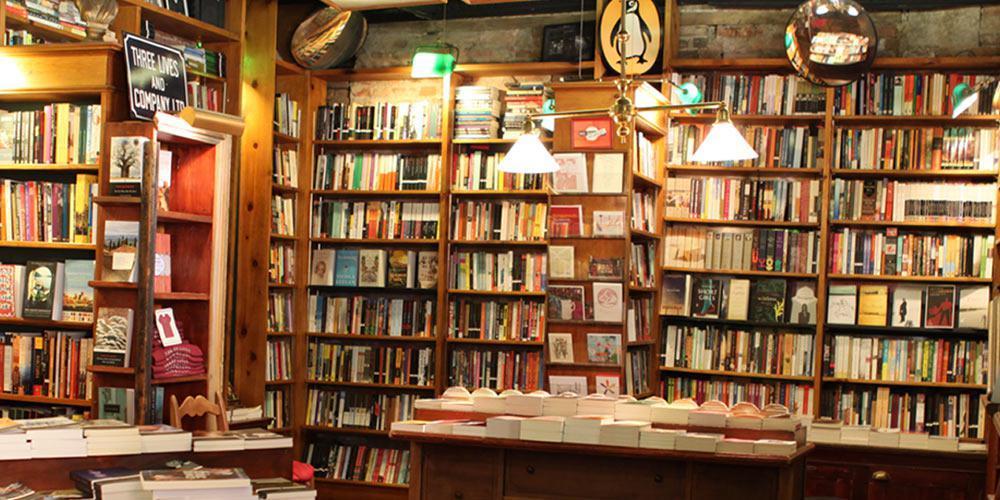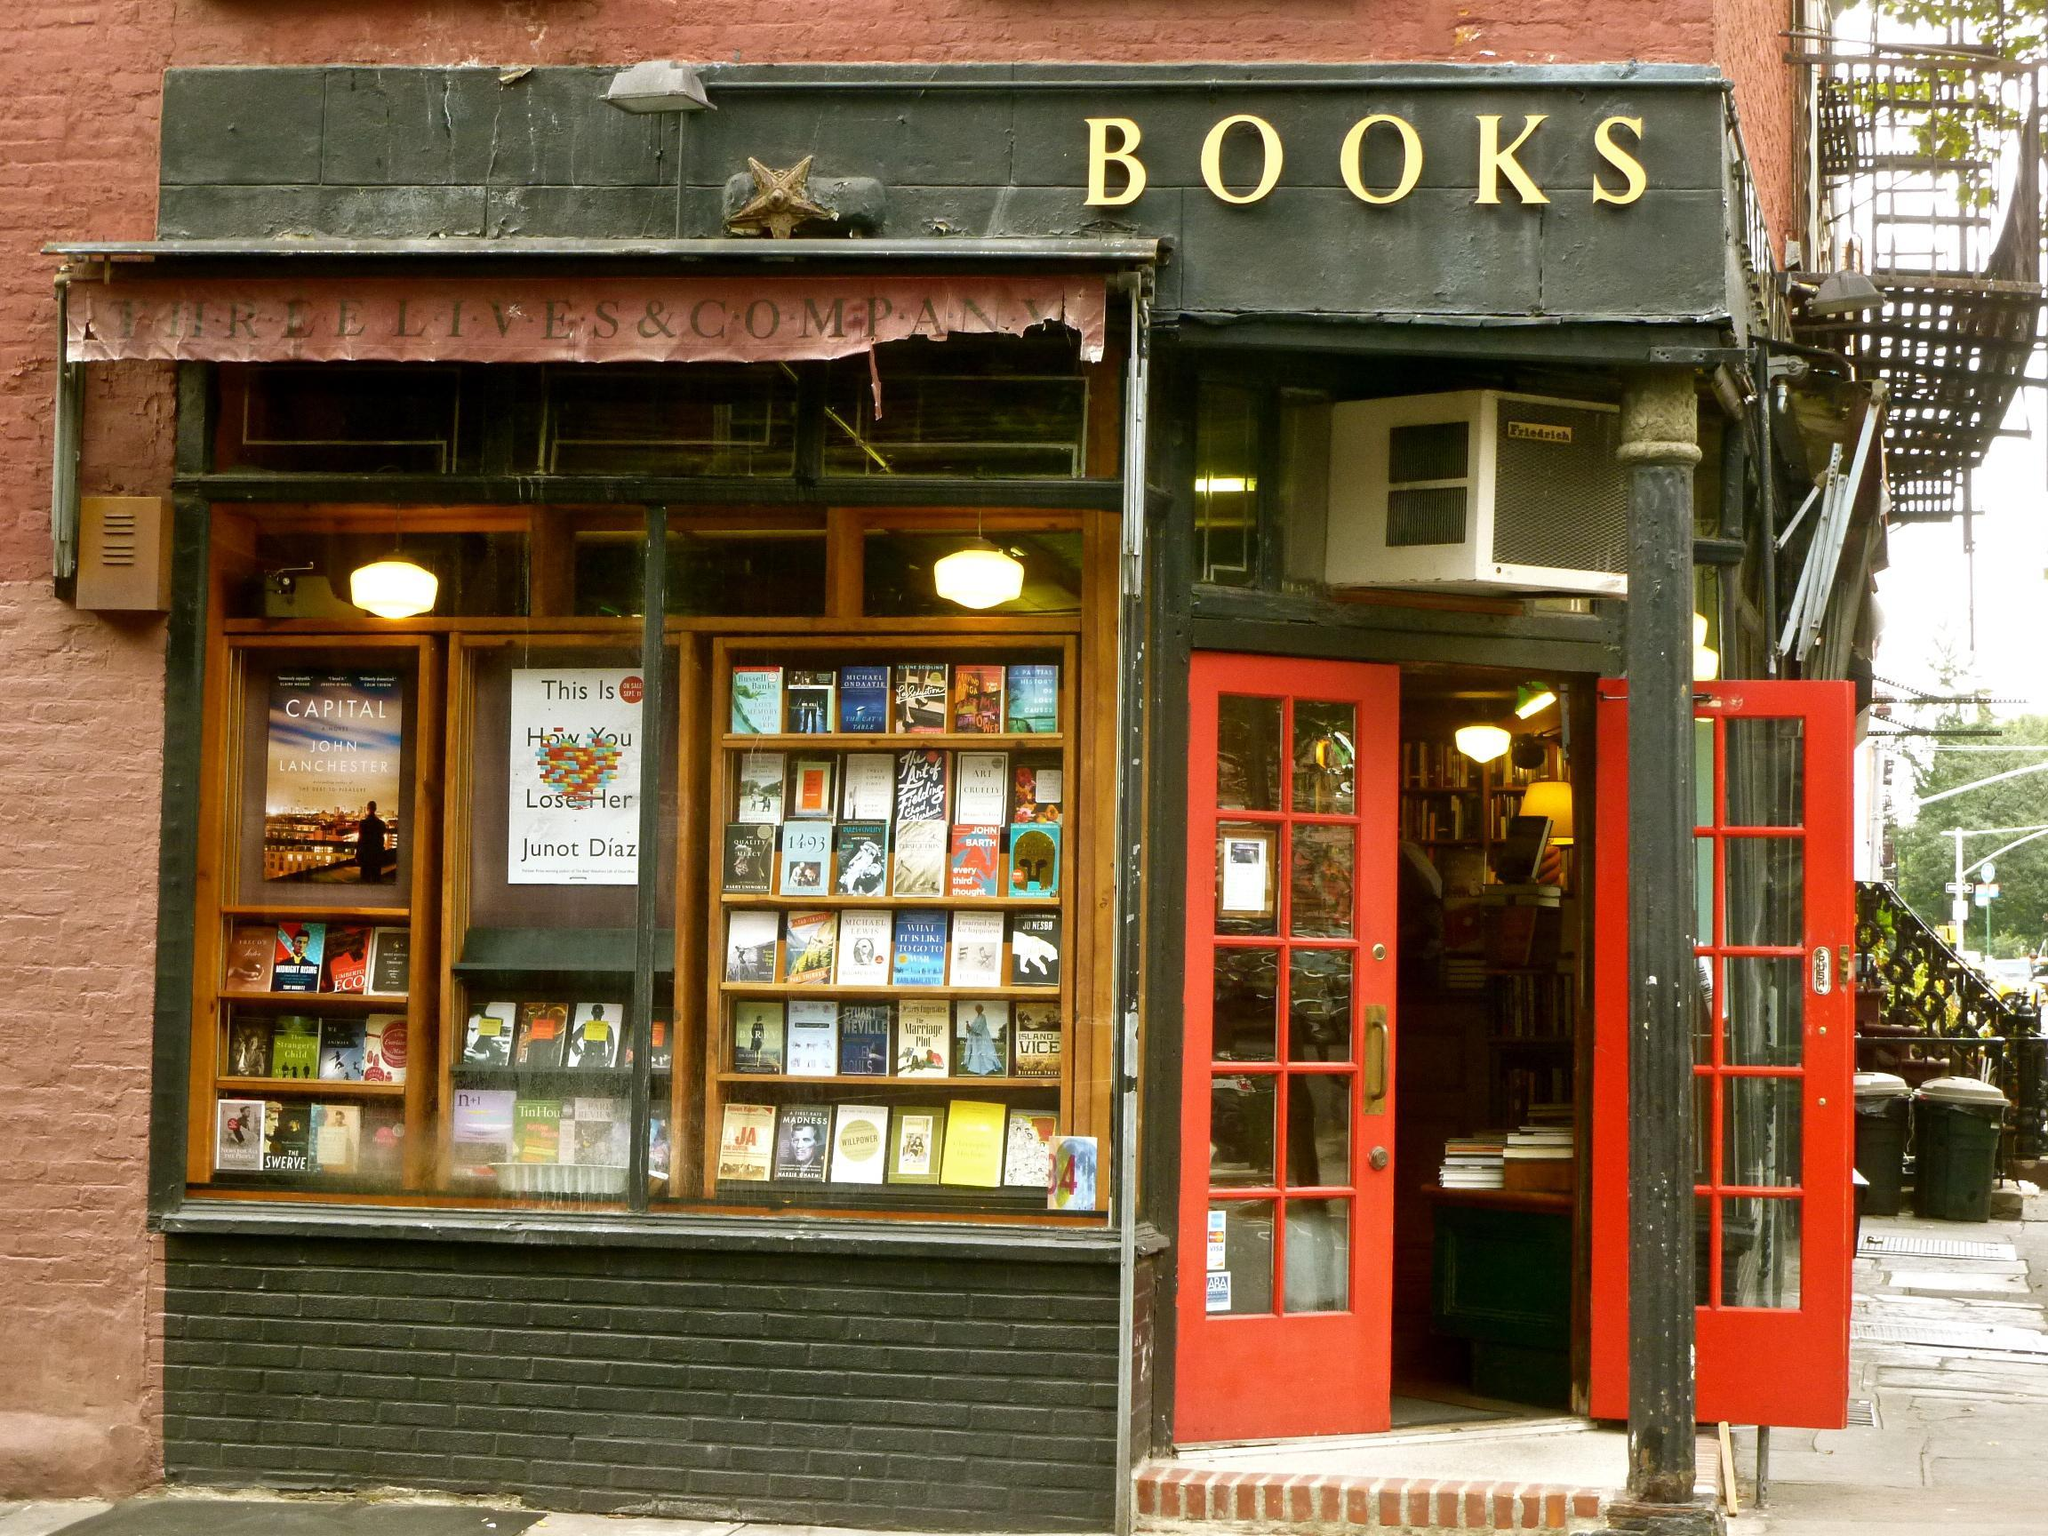The first image is the image on the left, the second image is the image on the right. Given the left and right images, does the statement "In one image there is a bookstore on a street corner with a red door that is open." hold true? Answer yes or no. Yes. The first image is the image on the left, the second image is the image on the right. For the images shown, is this caption "There is one image taken of the inside of the bookstore" true? Answer yes or no. Yes. 